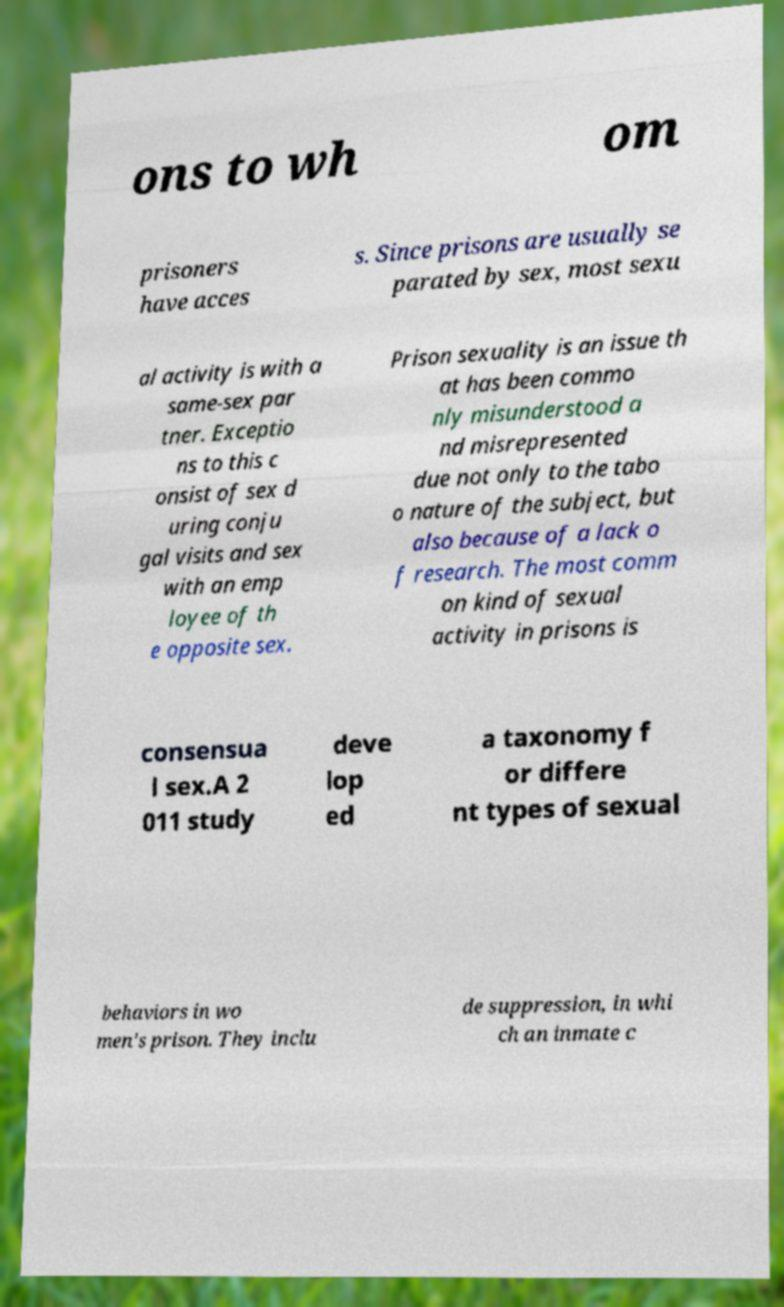Please read and relay the text visible in this image. What does it say? ons to wh om prisoners have acces s. Since prisons are usually se parated by sex, most sexu al activity is with a same-sex par tner. Exceptio ns to this c onsist of sex d uring conju gal visits and sex with an emp loyee of th e opposite sex. Prison sexuality is an issue th at has been commo nly misunderstood a nd misrepresented due not only to the tabo o nature of the subject, but also because of a lack o f research. The most comm on kind of sexual activity in prisons is consensua l sex.A 2 011 study deve lop ed a taxonomy f or differe nt types of sexual behaviors in wo men's prison. They inclu de suppression, in whi ch an inmate c 